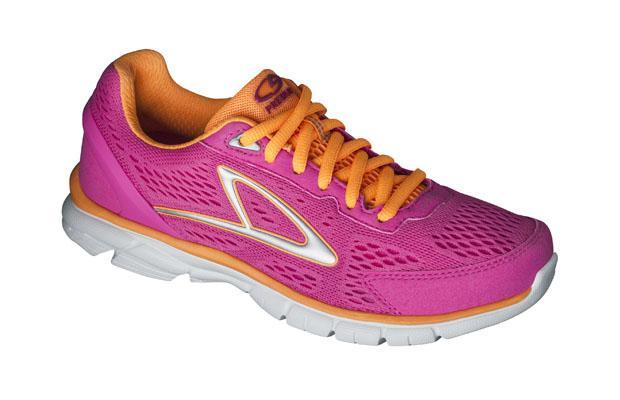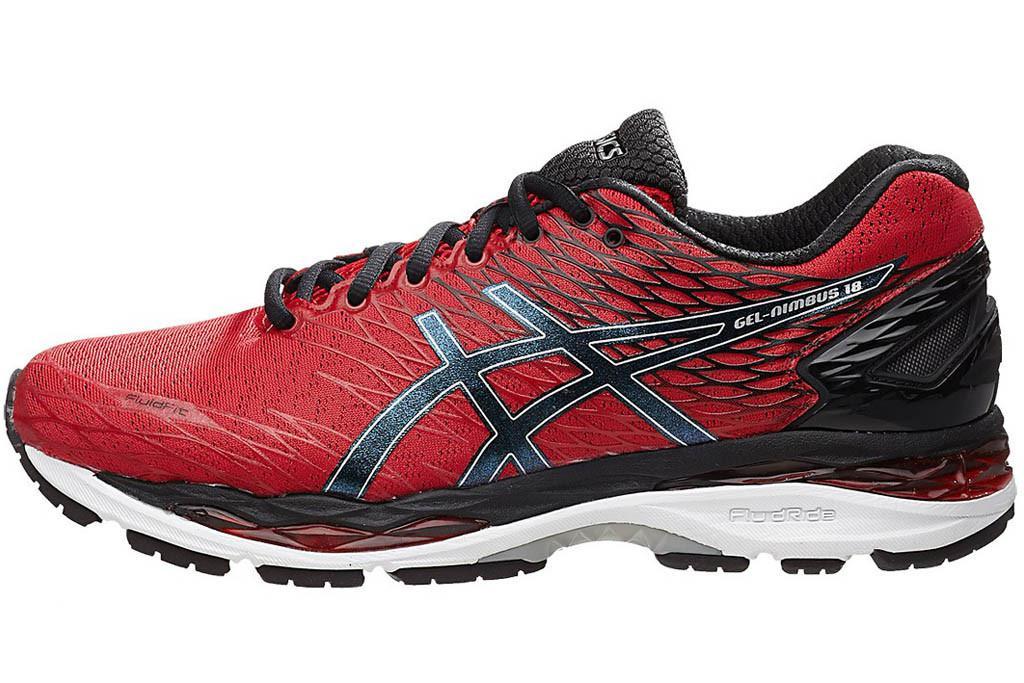The first image is the image on the left, the second image is the image on the right. Evaluate the accuracy of this statement regarding the images: "There is a red shoe with solid black laces.". Is it true? Answer yes or no. Yes. 